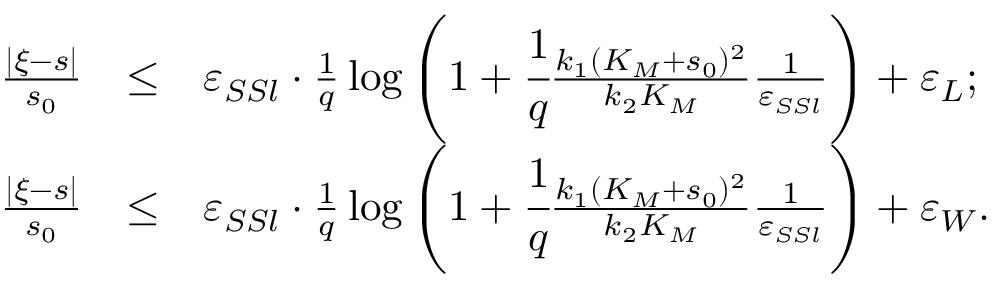Convert formula to latex. <formula><loc_0><loc_0><loc_500><loc_500>\begin{array} { r c l } { \frac { | \xi - s | } { s _ { 0 } } } & { \leq } & { \varepsilon _ { S S l } \cdot \frac { 1 } { q } \log \left ( 1 + \cfrac { 1 } { q } \frac { k _ { 1 } ( K _ { M } + s _ { 0 } ) ^ { 2 } } { k _ { 2 } K _ { M } } \frac { 1 } { \varepsilon _ { S S l } } \right ) + \varepsilon _ { L } ; } \\ { \frac { | \xi - s | } { s _ { 0 } } } & { \leq } & { \varepsilon _ { S S l } \cdot \frac { 1 } { q } \log \left ( 1 + \cfrac { 1 } { q } \frac { k _ { 1 } ( K _ { M } + s _ { 0 } ) ^ { 2 } } { k _ { 2 } K _ { M } } \frac { 1 } { \varepsilon _ { S S l } } \right ) + \varepsilon _ { W } . } \end{array}</formula> 